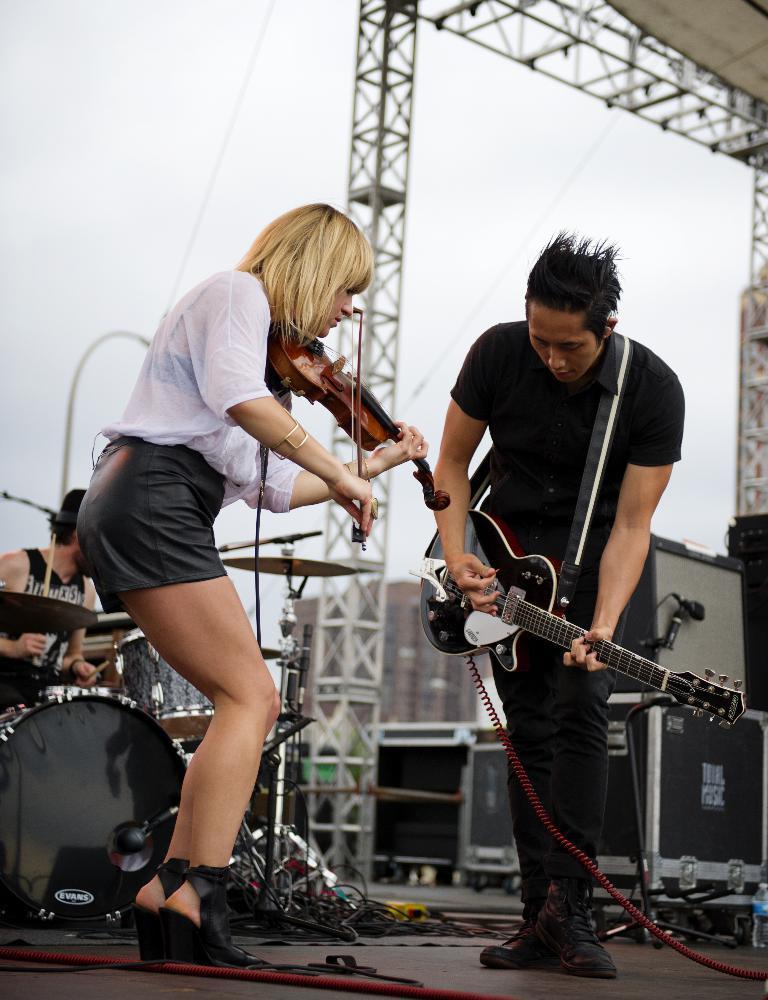Can you describe this image briefly? In the image we can see there is a woman and a man who are standing. The woman is holding a violin and the man is holding a guitar. They are standing on the stage, at the back there is a man who is playing the drums. 